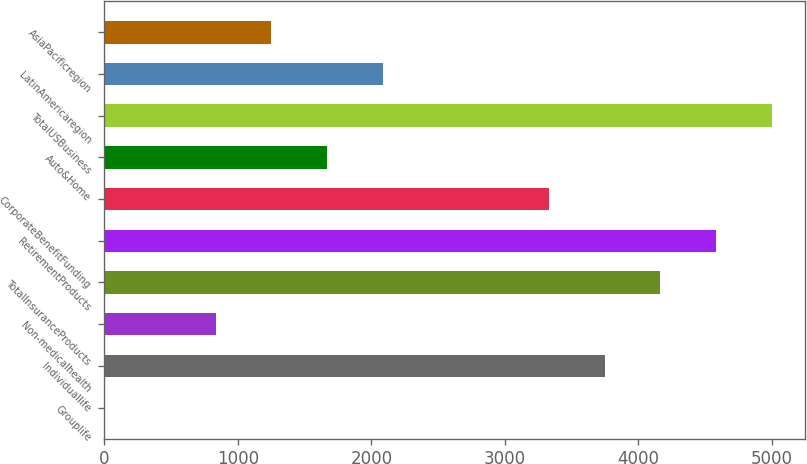Convert chart. <chart><loc_0><loc_0><loc_500><loc_500><bar_chart><fcel>Grouplife<fcel>Individuallife<fcel>Non-medicalhealth<fcel>TotalInsuranceProducts<fcel>RetirementProducts<fcel>CorporateBenefitFunding<fcel>Auto&Home<fcel>TotalUSBusiness<fcel>LatinAmericaregion<fcel>AsiaPacificregion<nl><fcel>2<fcel>3748.7<fcel>834.6<fcel>4165<fcel>4581.3<fcel>3332.4<fcel>1667.2<fcel>4997.6<fcel>2083.5<fcel>1250.9<nl></chart> 